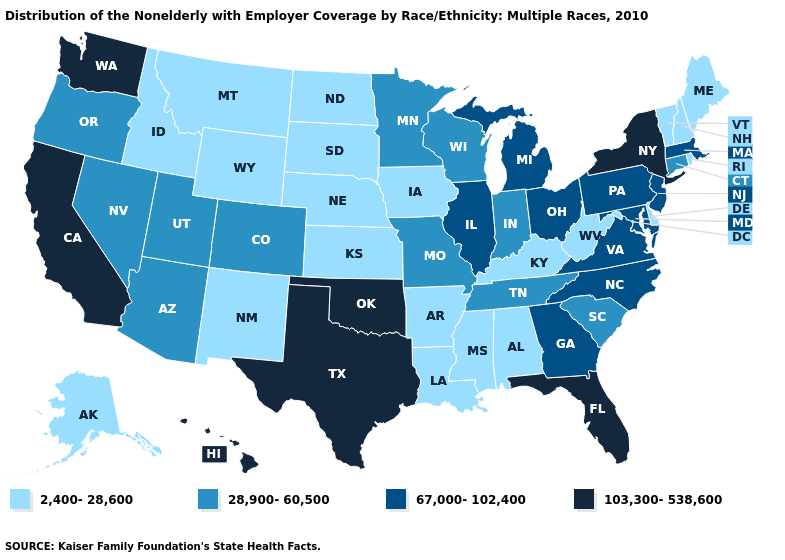Does New York have a higher value than Alabama?
Concise answer only. Yes. What is the value of Georgia?
Short answer required. 67,000-102,400. Among the states that border Connecticut , does New York have the lowest value?
Short answer required. No. Does Kansas have a higher value than Maine?
Keep it brief. No. Among the states that border Kansas , which have the lowest value?
Keep it brief. Nebraska. Name the states that have a value in the range 2,400-28,600?
Quick response, please. Alabama, Alaska, Arkansas, Delaware, Idaho, Iowa, Kansas, Kentucky, Louisiana, Maine, Mississippi, Montana, Nebraska, New Hampshire, New Mexico, North Dakota, Rhode Island, South Dakota, Vermont, West Virginia, Wyoming. What is the value of Mississippi?
Concise answer only. 2,400-28,600. Does New Jersey have the highest value in the USA?
Keep it brief. No. Name the states that have a value in the range 103,300-538,600?
Give a very brief answer. California, Florida, Hawaii, New York, Oklahoma, Texas, Washington. Does New York have the highest value in the USA?
Write a very short answer. Yes. Among the states that border Michigan , does Indiana have the lowest value?
Be succinct. Yes. Name the states that have a value in the range 67,000-102,400?
Answer briefly. Georgia, Illinois, Maryland, Massachusetts, Michigan, New Jersey, North Carolina, Ohio, Pennsylvania, Virginia. Name the states that have a value in the range 2,400-28,600?
Short answer required. Alabama, Alaska, Arkansas, Delaware, Idaho, Iowa, Kansas, Kentucky, Louisiana, Maine, Mississippi, Montana, Nebraska, New Hampshire, New Mexico, North Dakota, Rhode Island, South Dakota, Vermont, West Virginia, Wyoming. Name the states that have a value in the range 28,900-60,500?
Give a very brief answer. Arizona, Colorado, Connecticut, Indiana, Minnesota, Missouri, Nevada, Oregon, South Carolina, Tennessee, Utah, Wisconsin. How many symbols are there in the legend?
Keep it brief. 4. 